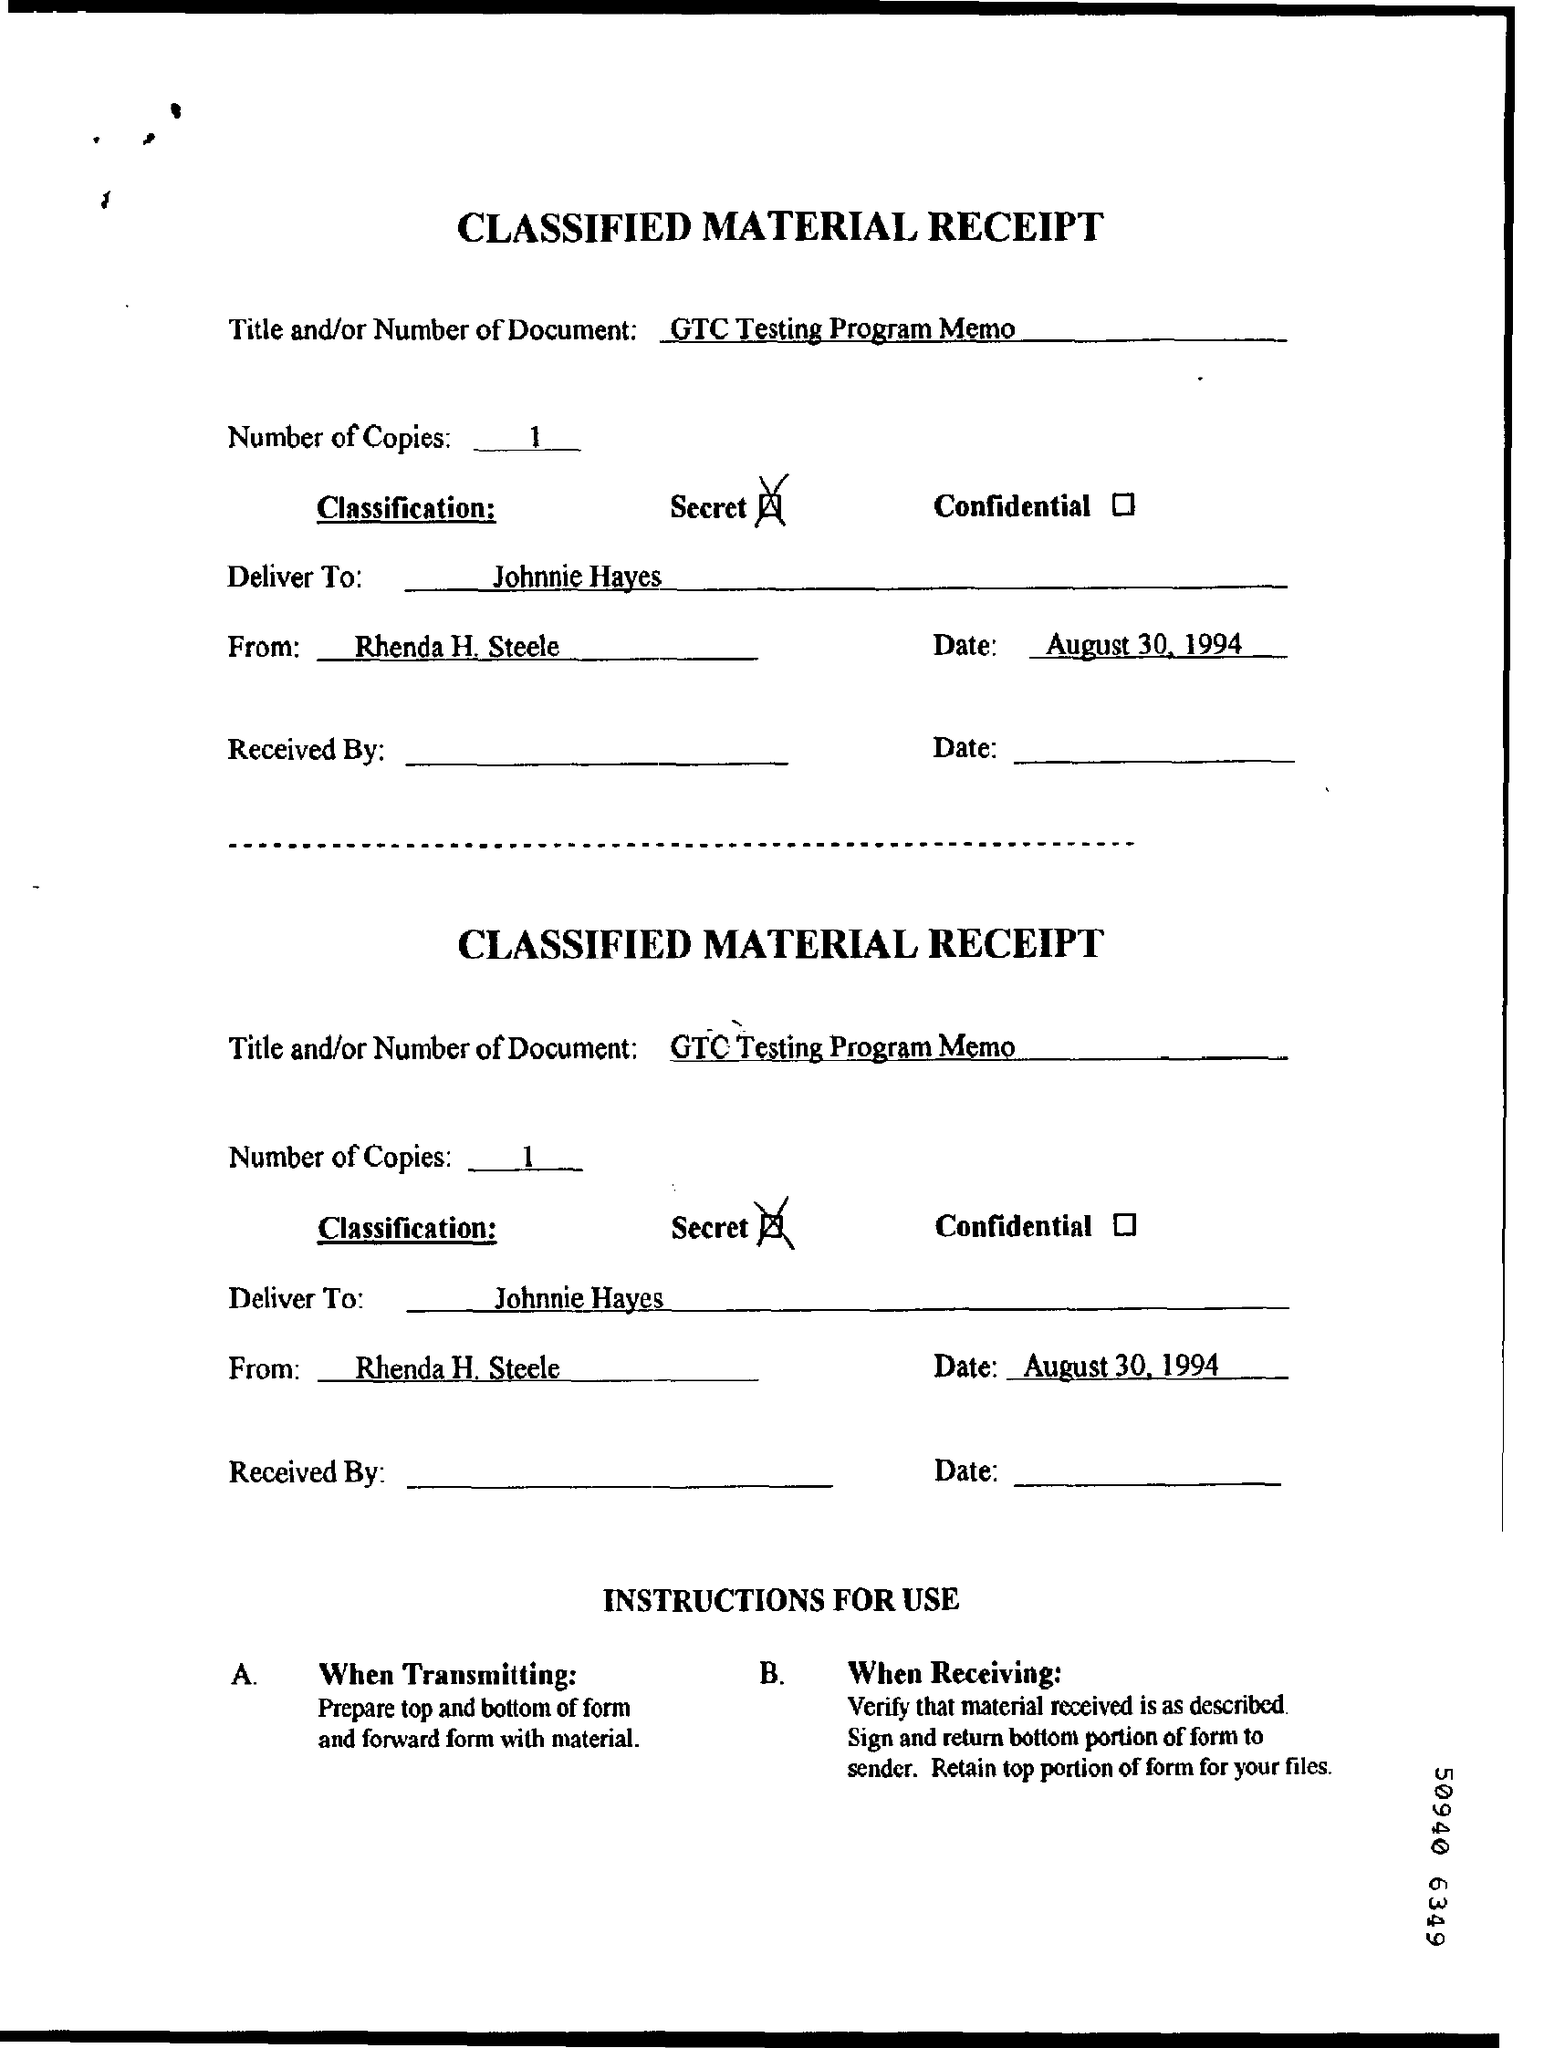What is written in the Title Field ?
Keep it short and to the point. GTC testing program memo. How many Copies are there ?
Ensure brevity in your answer.  1. Who is the Memorandum from ?
Make the answer very short. Rhenda H. Steele. 